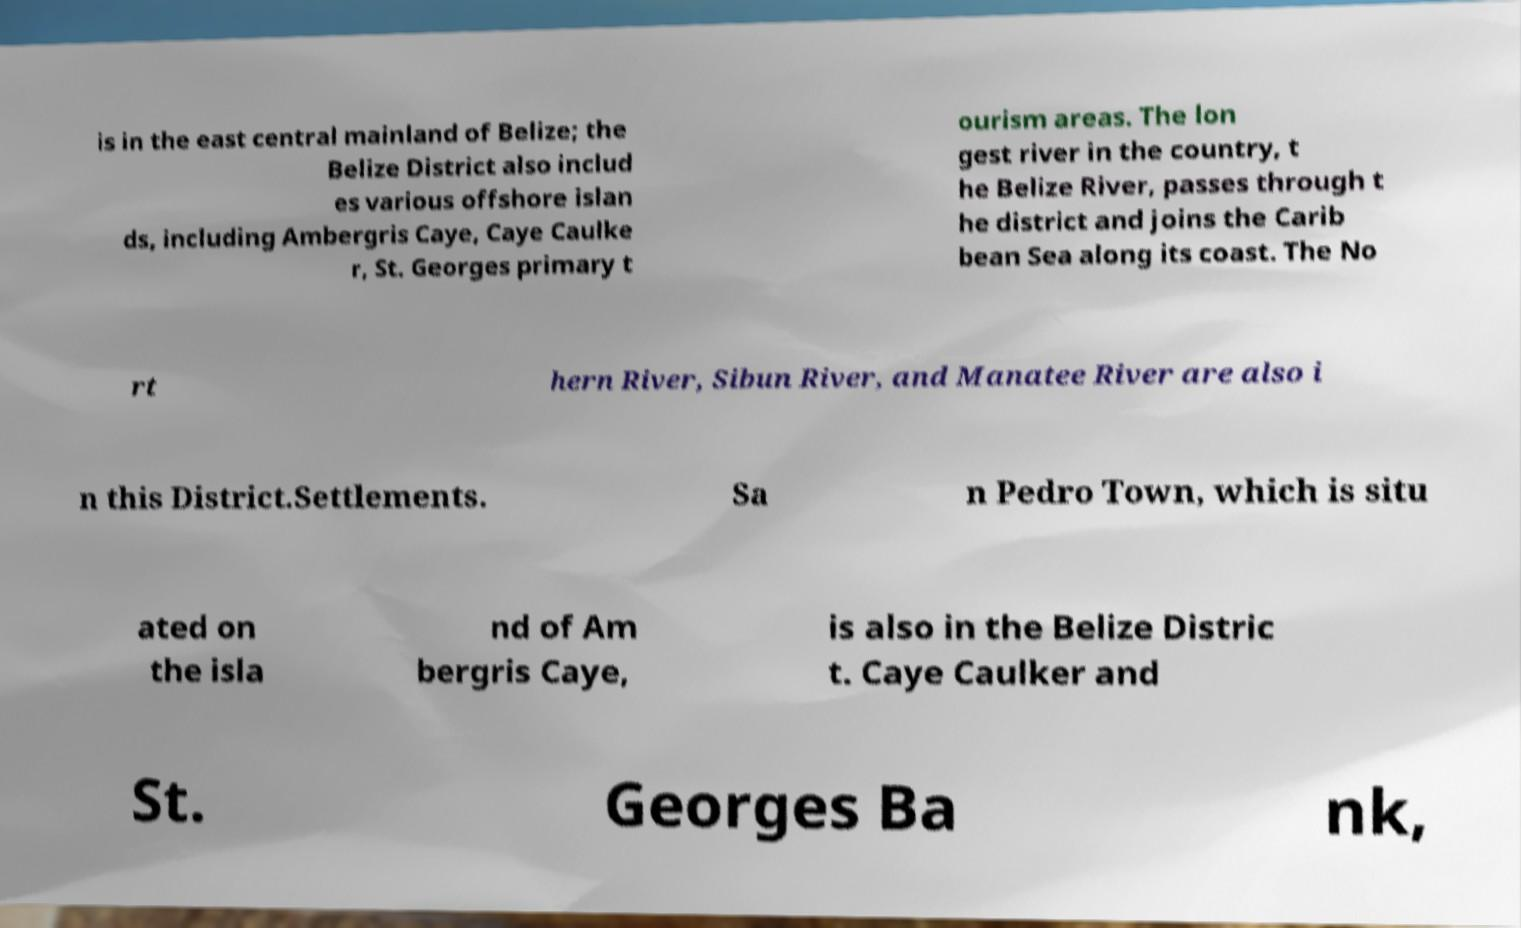Can you accurately transcribe the text from the provided image for me? is in the east central mainland of Belize; the Belize District also includ es various offshore islan ds, including Ambergris Caye, Caye Caulke r, St. Georges primary t ourism areas. The lon gest river in the country, t he Belize River, passes through t he district and joins the Carib bean Sea along its coast. The No rt hern River, Sibun River, and Manatee River are also i n this District.Settlements. Sa n Pedro Town, which is situ ated on the isla nd of Am bergris Caye, is also in the Belize Distric t. Caye Caulker and St. Georges Ba nk, 